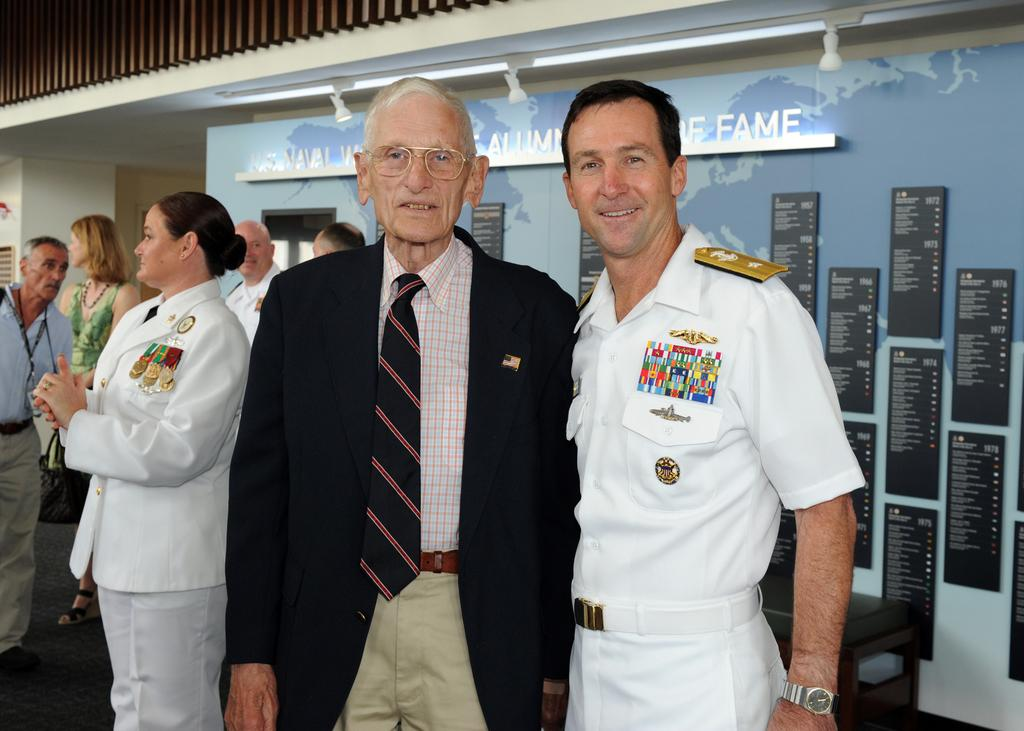<image>
Present a compact description of the photo's key features. Two men stand together at a U.S. Navy event. 